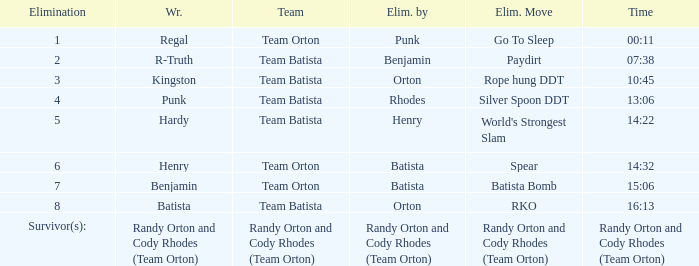Which Elimination Move is listed at Elimination 8 for Team Batista? RKO. 